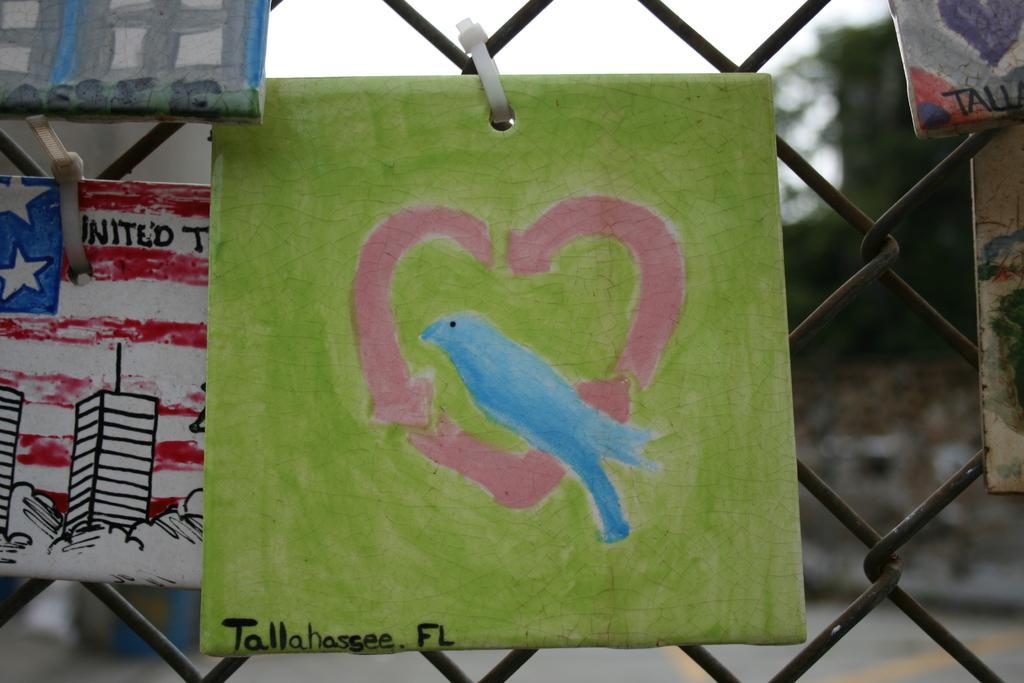In one or two sentences, can you explain what this image depicts? In this image I can see wall paintings and fence. In the background I can see the sky and trees. This image is taken during a day. 